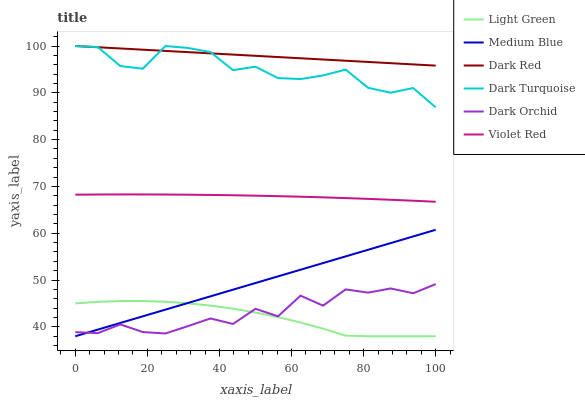Does Light Green have the minimum area under the curve?
Answer yes or no. Yes. Does Dark Red have the maximum area under the curve?
Answer yes or no. Yes. Does Medium Blue have the minimum area under the curve?
Answer yes or no. No. Does Medium Blue have the maximum area under the curve?
Answer yes or no. No. Is Medium Blue the smoothest?
Answer yes or no. Yes. Is Dark Orchid the roughest?
Answer yes or no. Yes. Is Dark Red the smoothest?
Answer yes or no. No. Is Dark Red the roughest?
Answer yes or no. No. Does Medium Blue have the lowest value?
Answer yes or no. Yes. Does Dark Red have the lowest value?
Answer yes or no. No. Does Dark Turquoise have the highest value?
Answer yes or no. Yes. Does Medium Blue have the highest value?
Answer yes or no. No. Is Violet Red less than Dark Turquoise?
Answer yes or no. Yes. Is Dark Red greater than Medium Blue?
Answer yes or no. Yes. Does Dark Red intersect Dark Turquoise?
Answer yes or no. Yes. Is Dark Red less than Dark Turquoise?
Answer yes or no. No. Is Dark Red greater than Dark Turquoise?
Answer yes or no. No. Does Violet Red intersect Dark Turquoise?
Answer yes or no. No. 